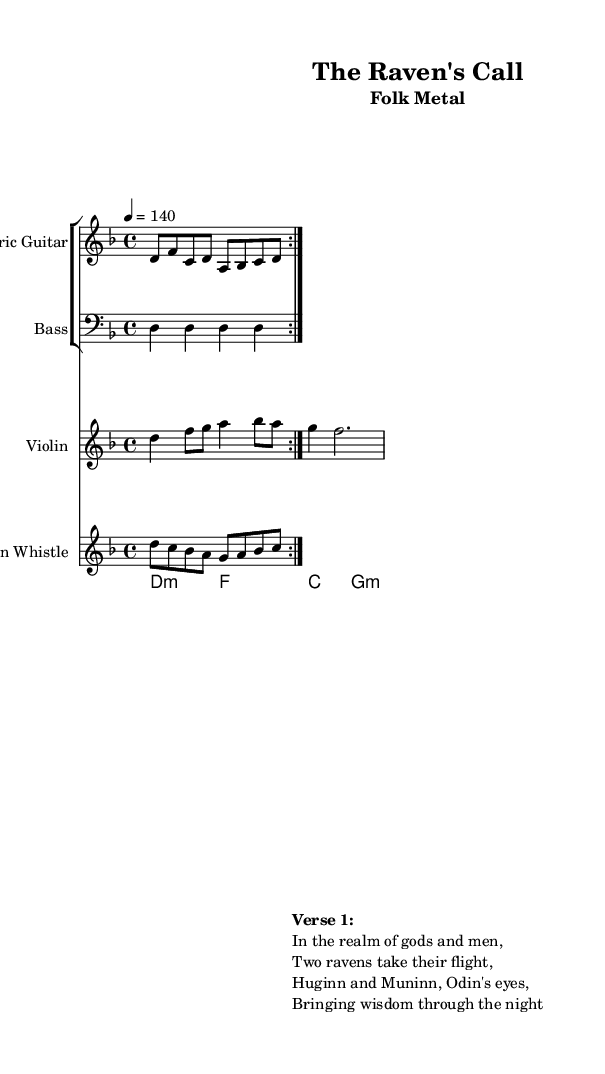What is the key signature of this music? The key signature is indicated as one flat, which corresponds to D minor.
Answer: D minor What is the time signature? The time signature is shown at the beginning of the score, indicating four beats in each measure.
Answer: 4/4 What is the tempo marking? The tempo marking is shown in the score, indicating the speed at which the piece should be played. It reads "4 = 140".
Answer: 140 How many times is the electric guitar section repeated? The notation "volta 2" indicates that the section is to be repeated two times.
Answer: 2 What instruments are part of this composition? By examining the score, we can see multiple staves indicating different instruments, including Electric Guitar, Bass, Violin, and Tin Whistle.
Answer: Electric Guitar, Bass, Violin, Tin Whistle What traditional story elements are referenced in the lyrics? The lyrics mention "Huginn and Muninn", which are mythological ravens from Norse mythology and relate specifically to the god Odin.
Answer: Norse mythology What characteristic of Folk Metal do the traditional instruments represent? The inclusion of instruments like the Tin Whistle and Violin emphasizes a connection to traditional folk music, which is a hallmark of the Folk Metal genre.
Answer: Traditional folk music 